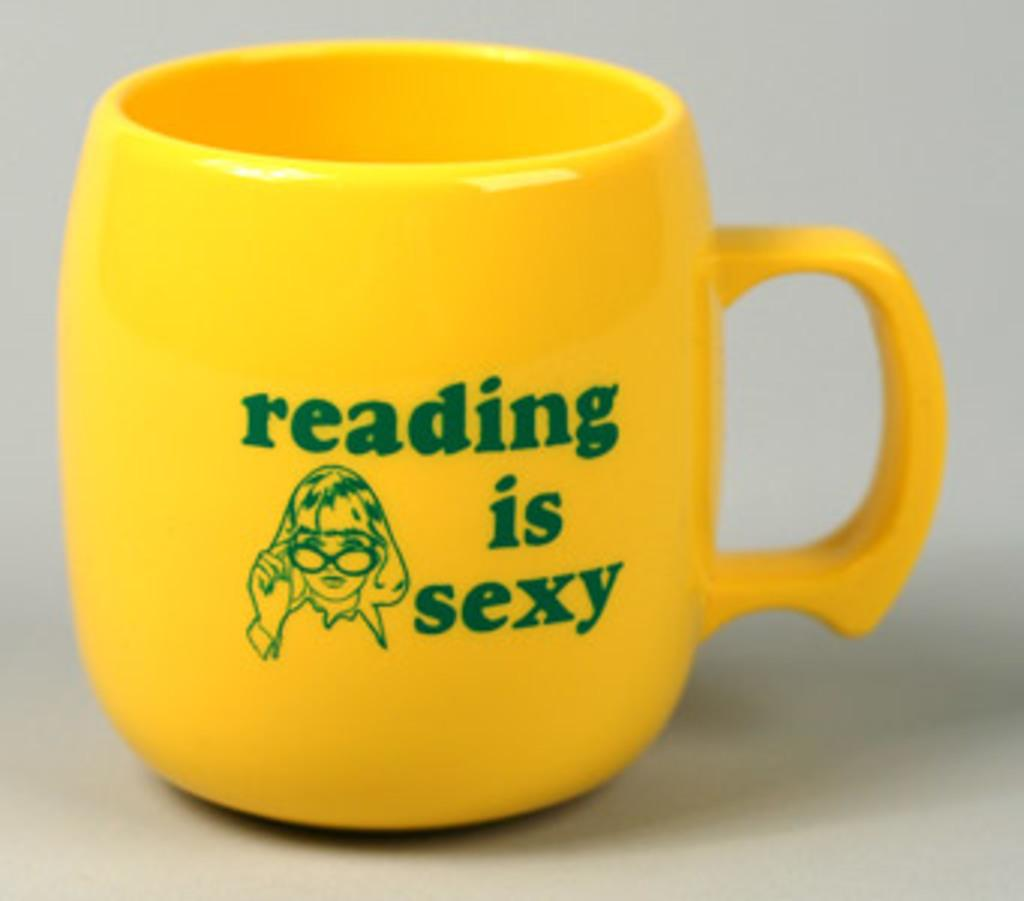Provide a one-sentence caption for the provided image. A yellow coffee cup that says reading is sexy. 